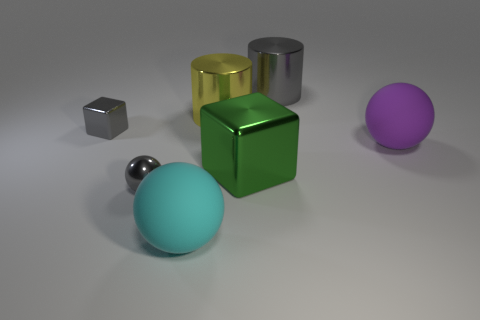Subtract all matte spheres. How many spheres are left? 1 Subtract 1 cylinders. How many cylinders are left? 1 Subtract all cyan balls. How many balls are left? 2 Add 3 purple matte spheres. How many objects exist? 10 Subtract all balls. How many objects are left? 4 Subtract all brown spheres. Subtract all blue cylinders. How many spheres are left? 3 Subtract all red balls. How many cyan cubes are left? 0 Subtract all tiny metallic spheres. Subtract all yellow objects. How many objects are left? 5 Add 3 metallic objects. How many metallic objects are left? 8 Add 3 metallic cubes. How many metallic cubes exist? 5 